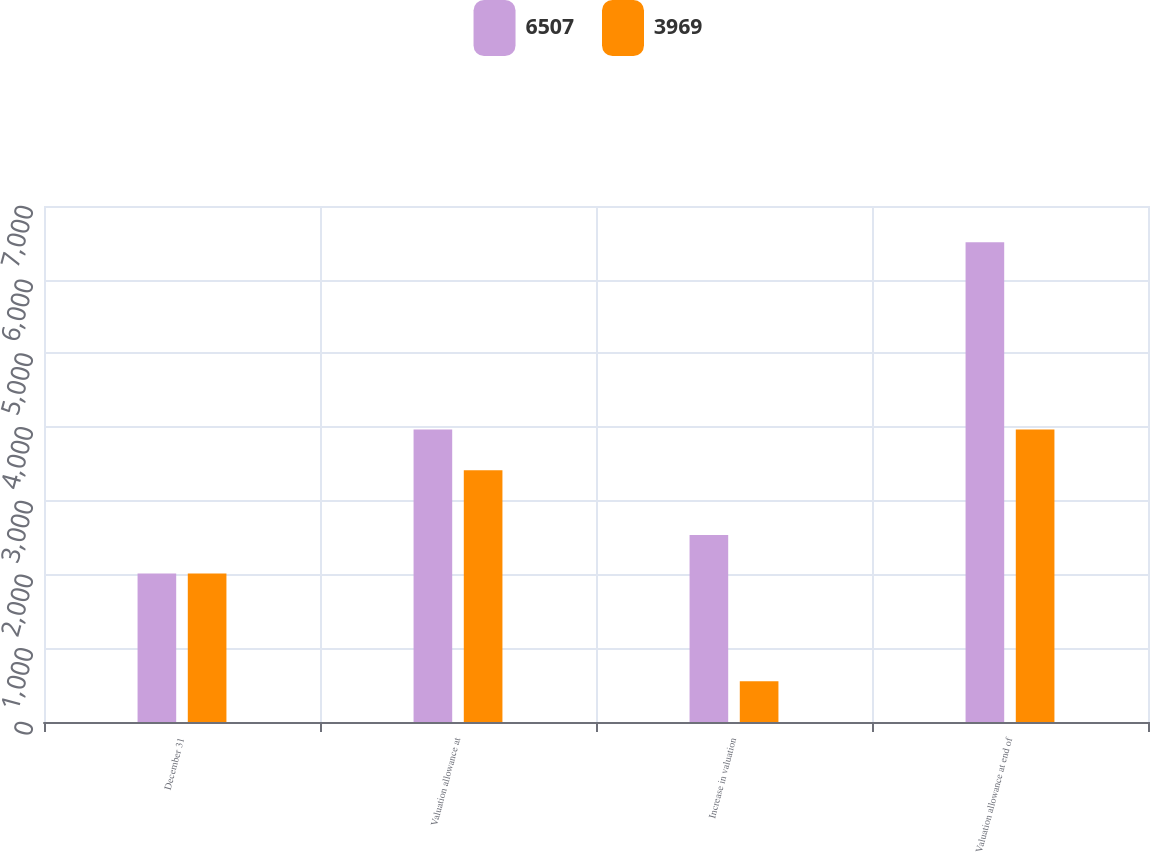<chart> <loc_0><loc_0><loc_500><loc_500><stacked_bar_chart><ecel><fcel>December 31<fcel>Valuation allowance at<fcel>Increase in valuation<fcel>Valuation allowance at end of<nl><fcel>6507<fcel>2016<fcel>3969<fcel>2538<fcel>6507<nl><fcel>3969<fcel>2015<fcel>3415<fcel>554<fcel>3969<nl></chart> 